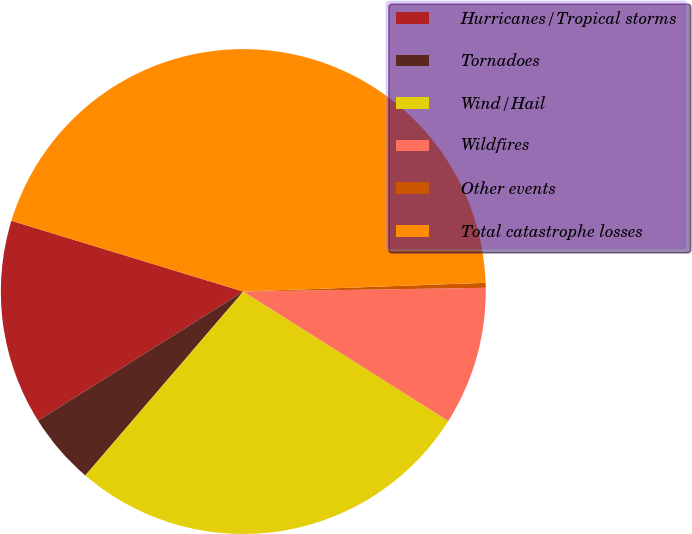Convert chart. <chart><loc_0><loc_0><loc_500><loc_500><pie_chart><fcel>Hurricanes/Tropical storms<fcel>Tornadoes<fcel>Wind/Hail<fcel>Wildfires<fcel>Other events<fcel>Total catastrophe losses<nl><fcel>13.65%<fcel>4.77%<fcel>27.33%<fcel>9.21%<fcel>0.33%<fcel>44.71%<nl></chart> 